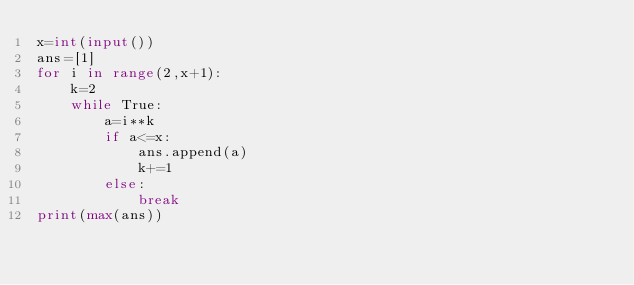Convert code to text. <code><loc_0><loc_0><loc_500><loc_500><_Python_>x=int(input())
ans=[1]
for i in range(2,x+1):
    k=2
    while True:
        a=i**k
        if a<=x:
            ans.append(a)
            k+=1
        else:
            break
print(max(ans))</code> 